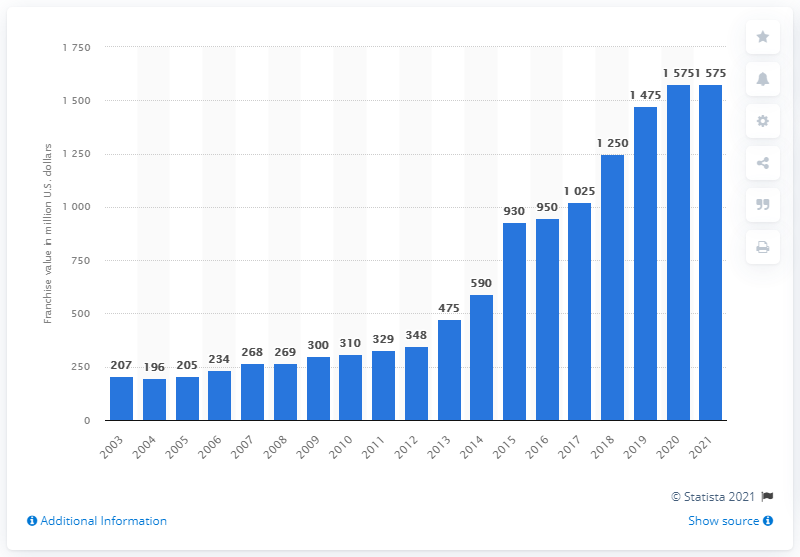Outline some significant characteristics in this image. The estimated value of the Oklahoma City Thunder in dollars in 2021 was approximately 1,575. 